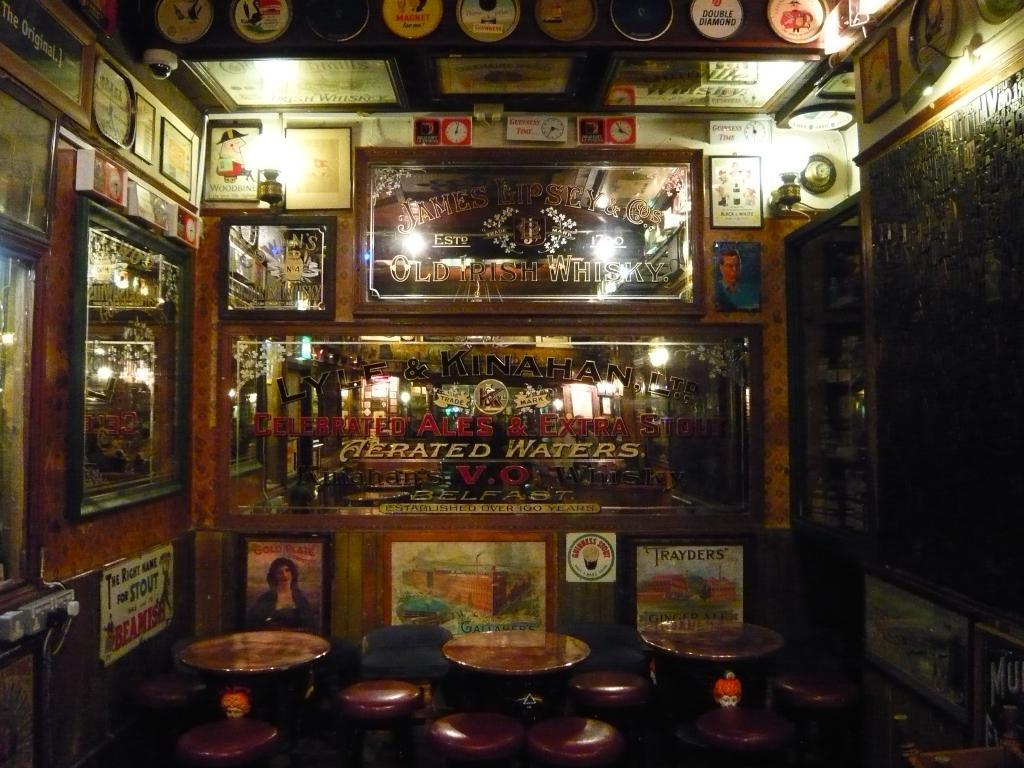What type of wall is visible in the image? There is a wooden wall in the image. What decorations are on the wooden wall? The wooden wall has photo frames and wall clocks on it. What type of furniture is on the floor in the image? There are seats on the floor in the image. How many bags of popcorn are on the wooden wall in the image? There is no popcorn present in the image; it only features photo frames and wall clocks on the wooden wall. 